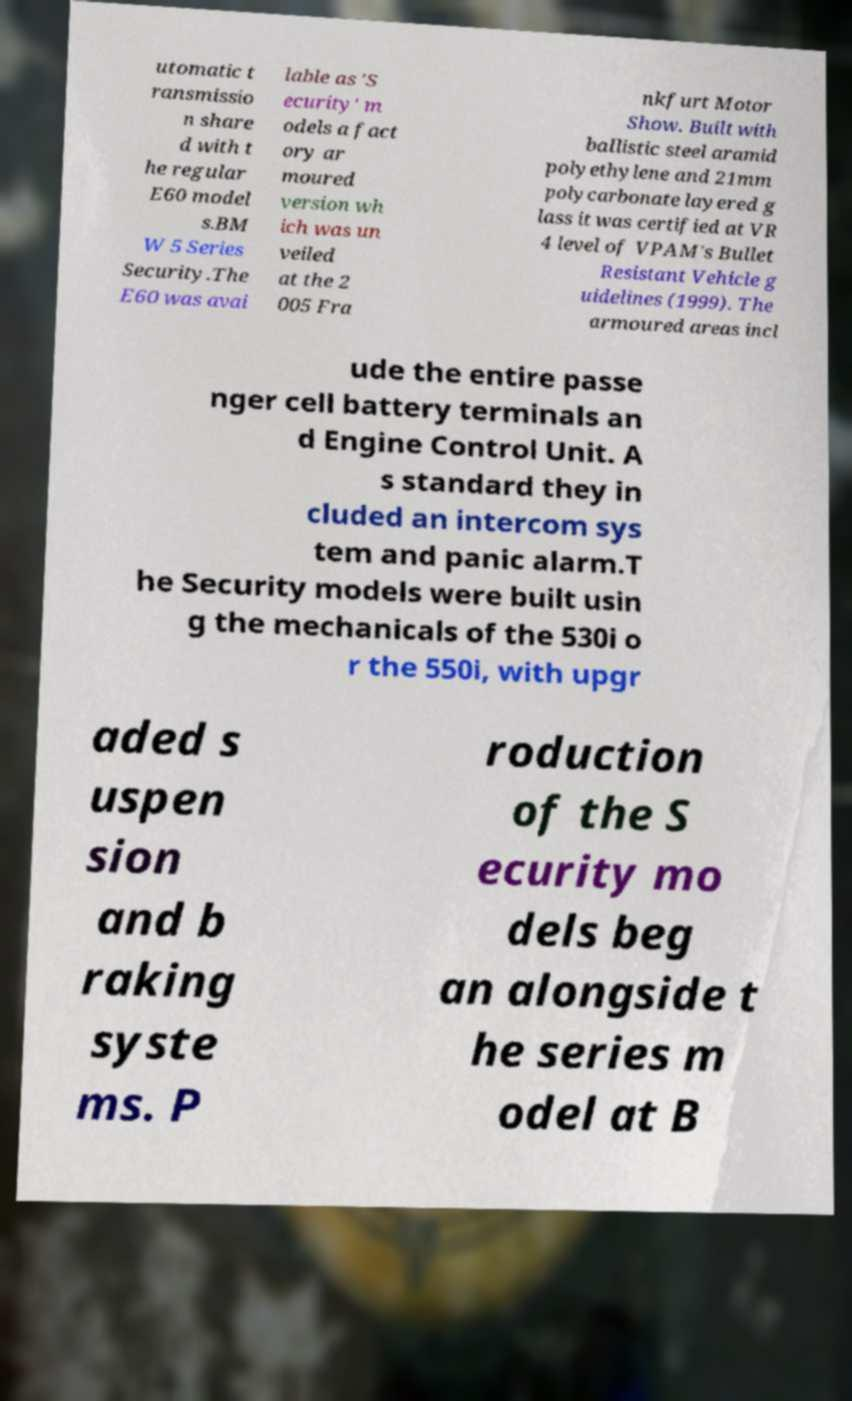For documentation purposes, I need the text within this image transcribed. Could you provide that? utomatic t ransmissio n share d with t he regular E60 model s.BM W 5 Series Security.The E60 was avai lable as 'S ecurity' m odels a fact ory ar moured version wh ich was un veiled at the 2 005 Fra nkfurt Motor Show. Built with ballistic steel aramid polyethylene and 21mm polycarbonate layered g lass it was certified at VR 4 level of VPAM's Bullet Resistant Vehicle g uidelines (1999). The armoured areas incl ude the entire passe nger cell battery terminals an d Engine Control Unit. A s standard they in cluded an intercom sys tem and panic alarm.T he Security models were built usin g the mechanicals of the 530i o r the 550i, with upgr aded s uspen sion and b raking syste ms. P roduction of the S ecurity mo dels beg an alongside t he series m odel at B 